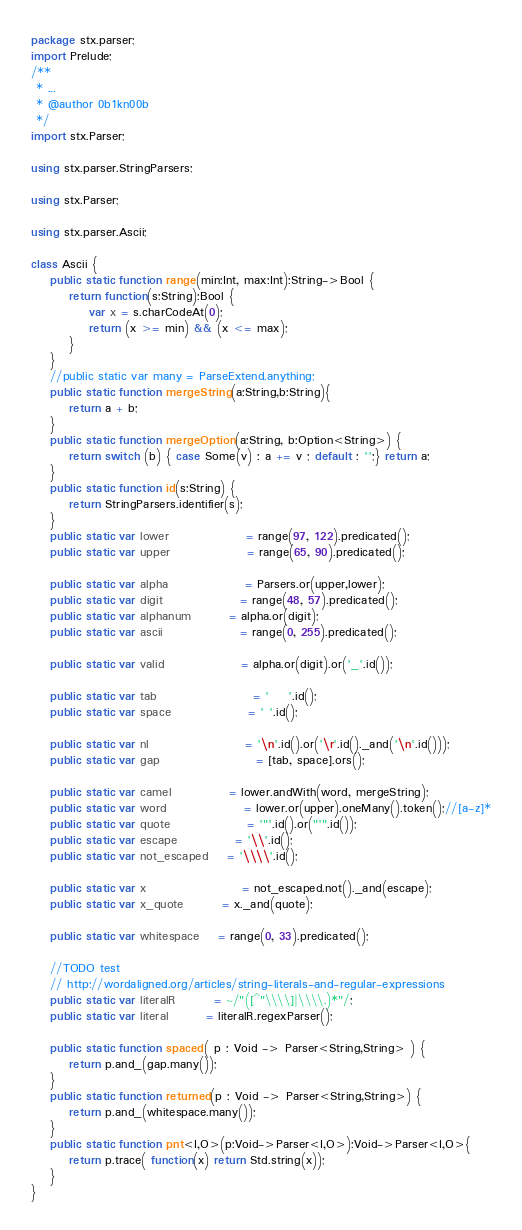Convert code to text. <code><loc_0><loc_0><loc_500><loc_500><_Haxe_>package stx.parser;
import Prelude;
/**
 * ...
 * @author 0b1kn00b
 */
import stx.Parser;

using stx.parser.StringParsers;

using stx.Parser;

using stx.parser.Ascii;

class Ascii {
	public static function range(min:Int, max:Int):String->Bool {
		return function(s:String):Bool {
			var x = s.charCodeAt(0);
			return (x >= min) && (x <= max);
		}
	}
	//public static var many = ParseExtend.anything;
	public static function mergeString(a:String,b:String){
		return a + b;
	}
	public static function mergeOption(a:String, b:Option<String>) {
		return switch (b) { case Some(v) : a += v ; default : '';} return a; 
	}
	public static function id(s:String) {
		return StringParsers.identifier(s);
	}
	public static var lower				= range(97, 122).predicated();
	public static var upper				= range(65, 90).predicated();
	
	public static var alpha				= Parsers.or(upper,lower);
	public static var digit				= range(48, 57).predicated();
	public static var alphanum		= alpha.or(digit);
	public static var ascii				= range(0, 255).predicated();
	
	public static var valid				= alpha.or(digit).or('_'.id());
	
	public static var tab					= '	'.id();
	public static var space				= ' '.id();
	
	public static var nl					= '\n'.id().or('\r'.id()._and('\n'.id()));
	public static var gap					= [tab, space].ors();

	public static var camel 			= lower.andWith(word, mergeString);
	public static var word				= lower.or(upper).oneMany().token();//[a-z]*
	public static var quote				= '"'.id().or("'".id());
	public static var escape			= '\\'.id();
	public static var not_escaped	= '\\\\'.id();
	
	public static var x 					= not_escaped.not()._and(escape);
	public static var x_quote 		= x._and(quote);
	
 	public static var whitespace	= range(0, 33).predicated();
	
	//TODO test
	// http://wordaligned.org/articles/string-literals-and-regular-expressions
	public static var literalR		= ~/"([^"\\\\]|\\\\.)*"/;
	public static var literal 		= literalR.regexParser();
	
	public static function spaced( p : Void -> Parser<String,String> ) {
		return p.and_(gap.many());
	}
	public static function returned(p : Void -> Parser<String,String>) {
		return p.and_(whitespace.many());
	}
	public static function pnt<I,O>(p:Void->Parser<I,O>):Void->Parser<I,O>{
		return p.trace( function(x) return Std.string(x));
	}
}</code> 